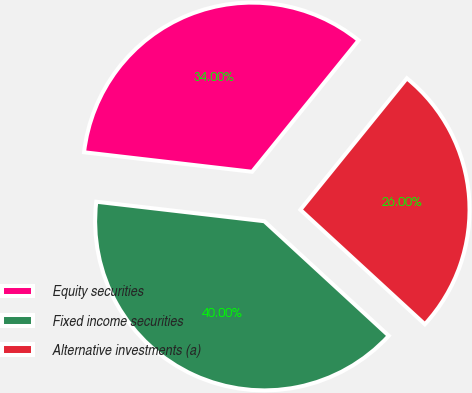<chart> <loc_0><loc_0><loc_500><loc_500><pie_chart><fcel>Equity securities<fcel>Fixed income securities<fcel>Alternative investments (a)<nl><fcel>34.0%<fcel>40.0%<fcel>26.0%<nl></chart> 